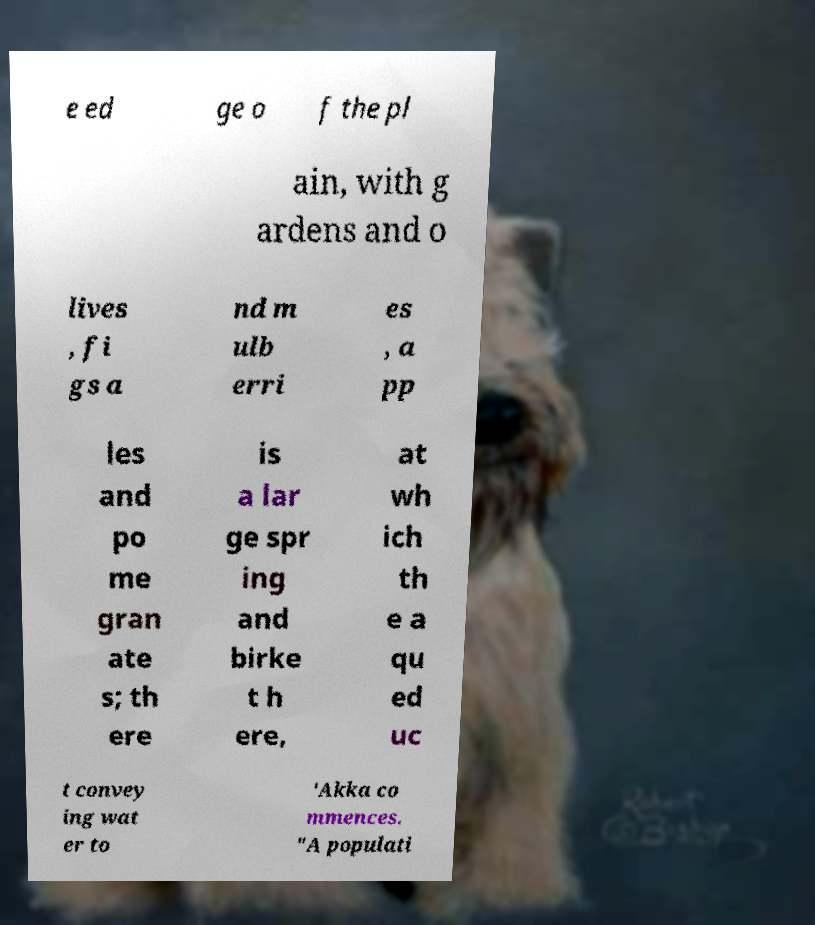Could you extract and type out the text from this image? e ed ge o f the pl ain, with g ardens and o lives , fi gs a nd m ulb erri es , a pp les and po me gran ate s; th ere is a lar ge spr ing and birke t h ere, at wh ich th e a qu ed uc t convey ing wat er to 'Akka co mmences. "A populati 